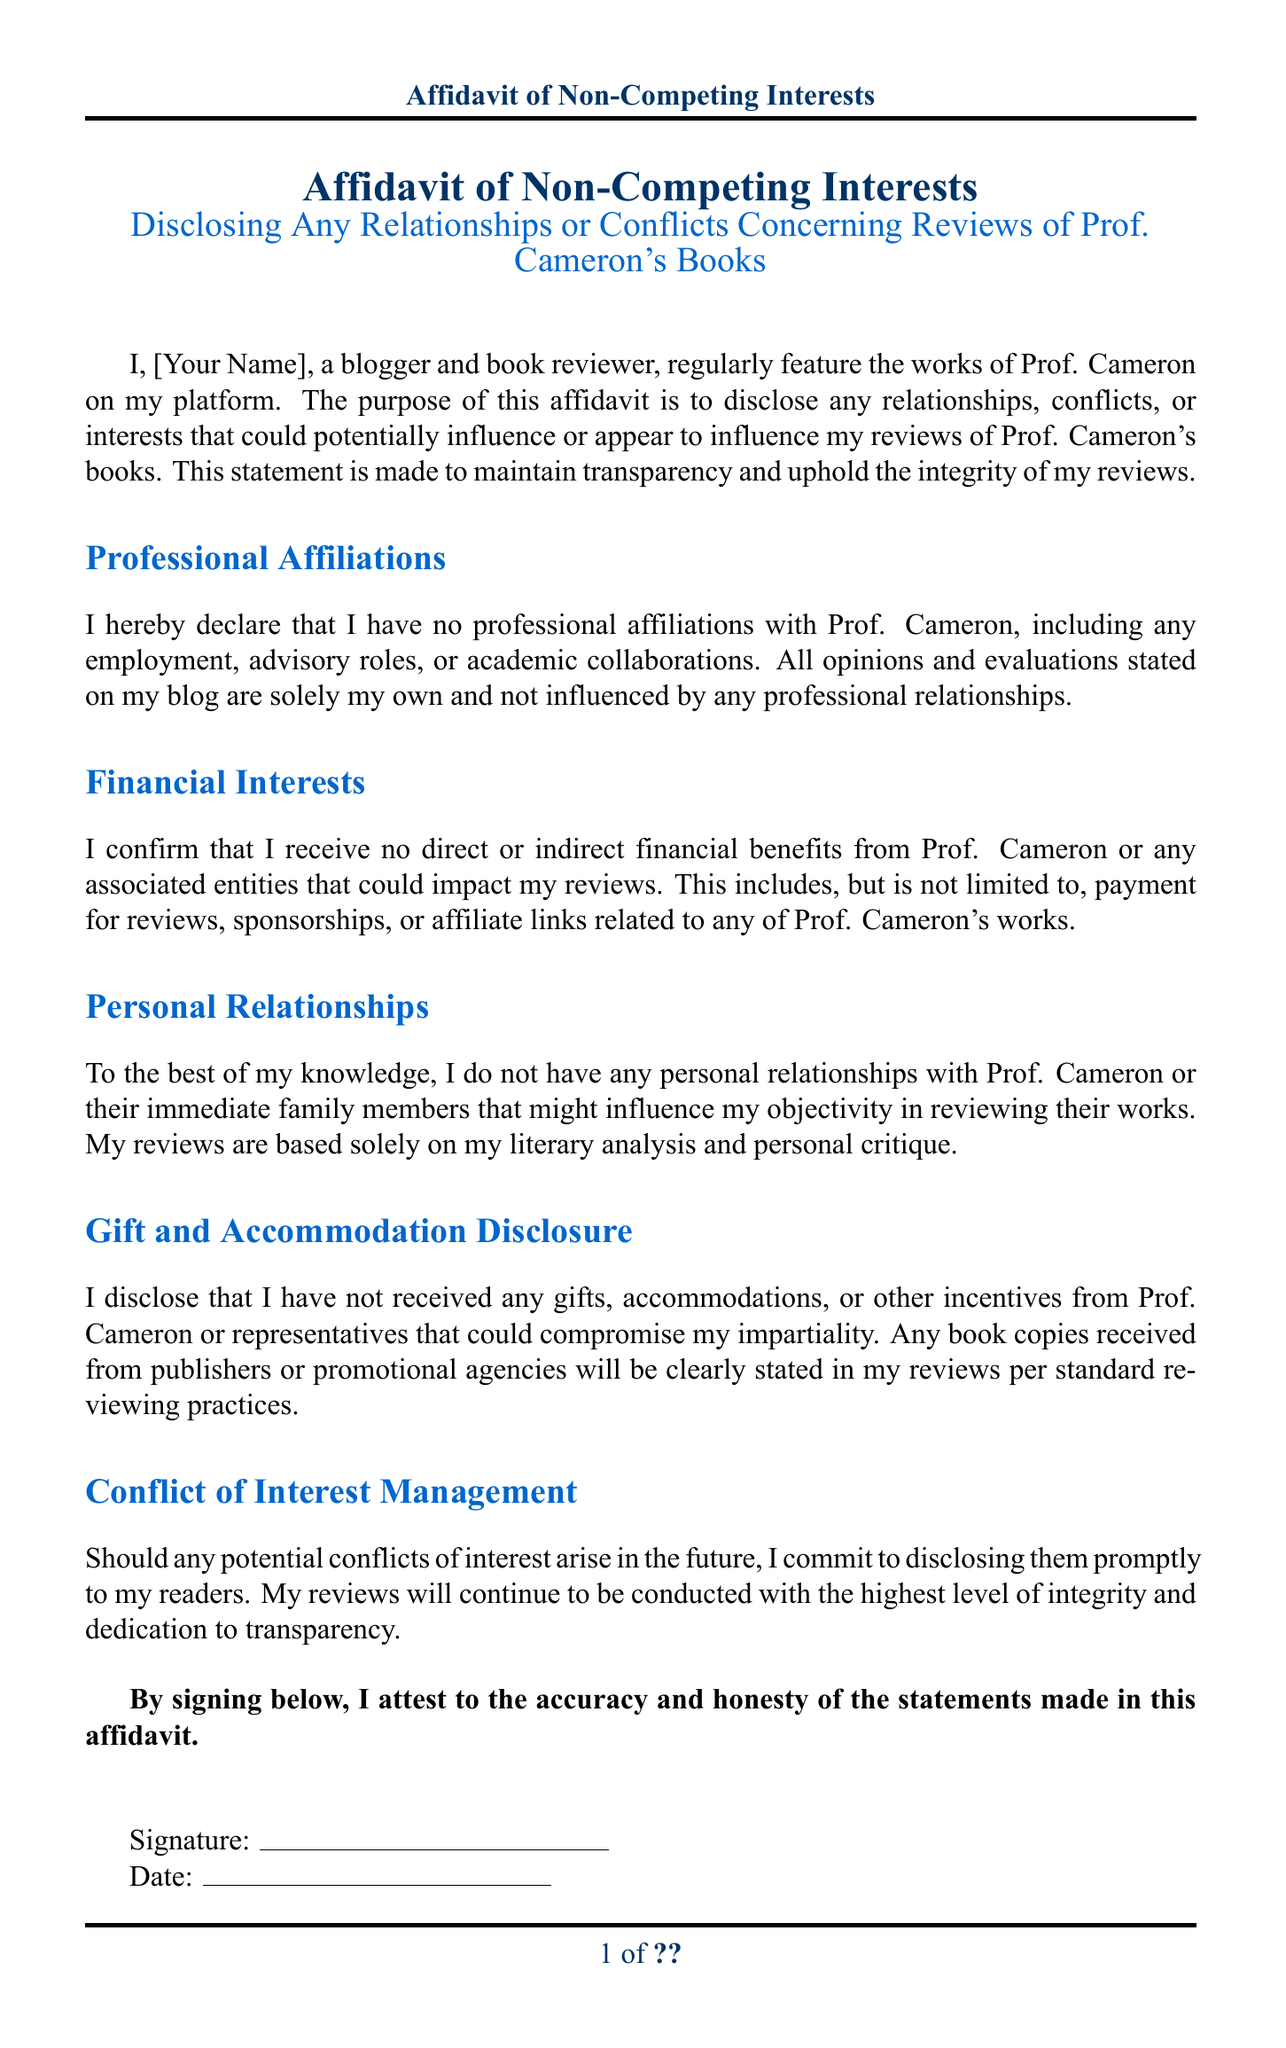What is the title of the document? The title is prominently displayed at the beginning of the document as "Affidavit of Non-Competing Interests."
Answer: Affidavit of Non-Competing Interests Who is the author of the affidavit? The author is identified as "[Your Name]" in the document, indicating that it should be filled in with the signer's name.
Answer: [Your Name] What section discusses financial interests? The relevant section is titled "Financial Interests," where disclosures about monetary relationships are made.
Answer: Financial Interests What is the purpose of this affidavit? The purpose is stated as disclosing any relationships, conflicts, or interests that could influence reviews.
Answer: To maintain transparency What commitment does the author make regarding future conflicts? The author commits to disclosing any potential conflicts of interest that arise in the future.
Answer: Disclosing them promptly What should be stated in the reviews about received book copies? It is mentioned that any book copies received must be clearly stated in the reviews in accordance with standard reviewing practices.
Answer: Clearly stated What is the significance of the signature at the end? The signature indicates the author's attestation to the accuracy and honesty of the statements made in the affidavit.
Answer: Attest to accuracy What color is used for the document title? The document title is rendered in a specific color, which is identified as "#003366" in RGB.
Answer: Title color What actions should the author take if conflicts arise? The author should disclose any potential conflicts promptly to their readers as part of their commitment.
Answer: Disclose promptly 